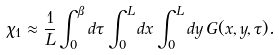Convert formula to latex. <formula><loc_0><loc_0><loc_500><loc_500>\chi _ { 1 } \approx \frac { 1 } { L } \int _ { 0 } ^ { \beta } d \tau \int _ { 0 } ^ { L } d x \int _ { 0 } ^ { L } d y \, G ( x , y , \tau ) .</formula> 